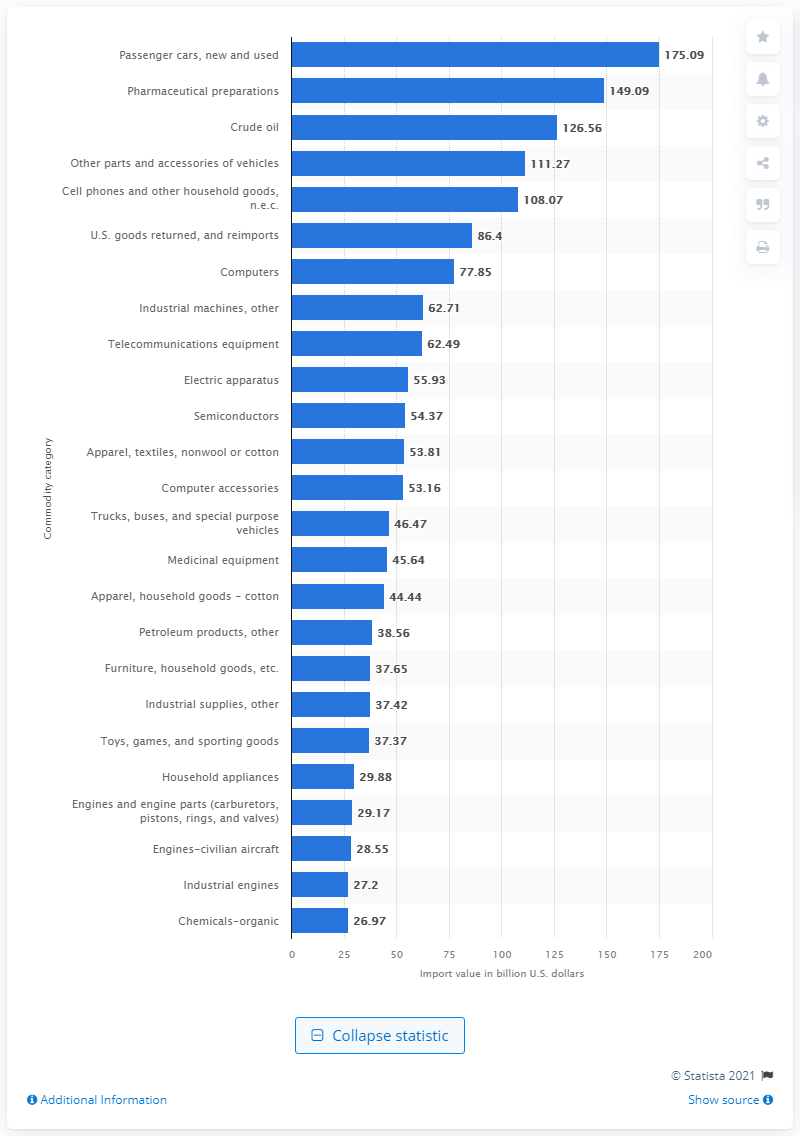List a handful of essential elements in this visual. In 2019, the total value of passenger car imports to the United States was $175.09 million. 